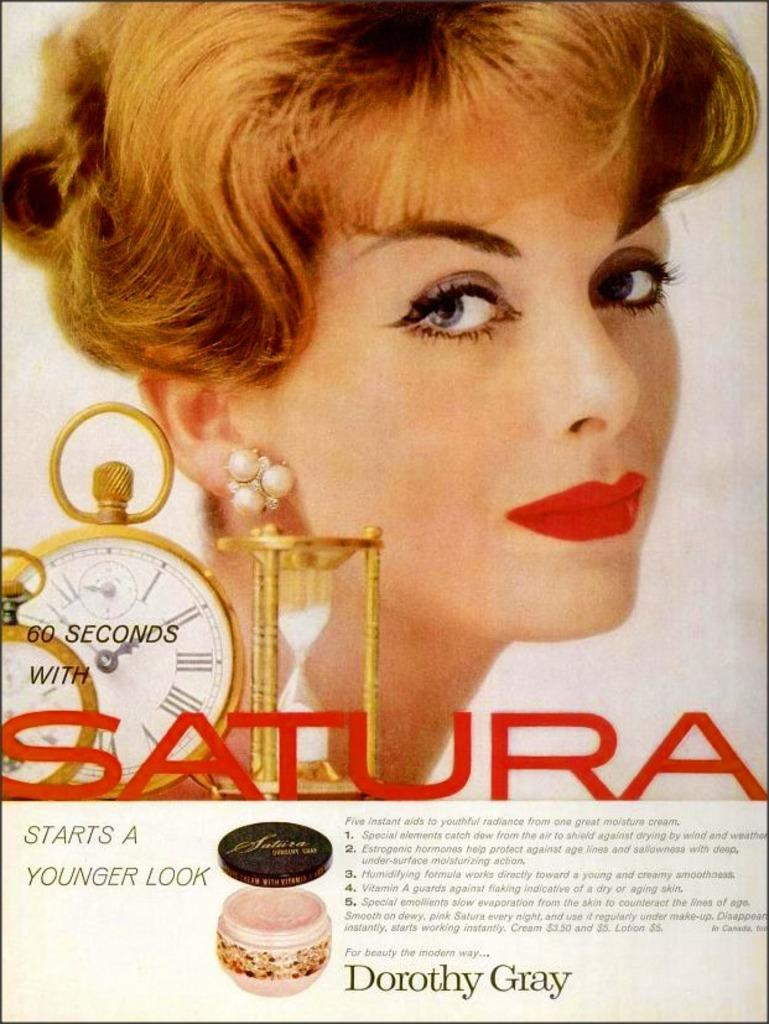Provide a one-sentence caption for the provided image. A page from a magazine that is advertising Satura. 